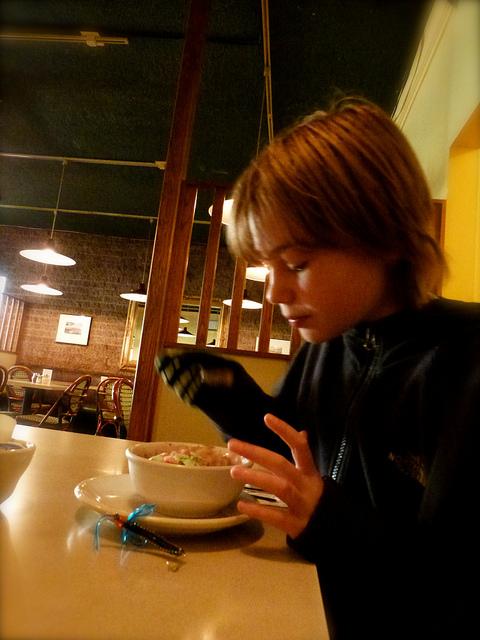Could this be a restaurant?
Be succinct. Yes. What is this person doing?
Quick response, please. Eating. What is on the hand of the person eating?
Write a very short answer. Glove. 